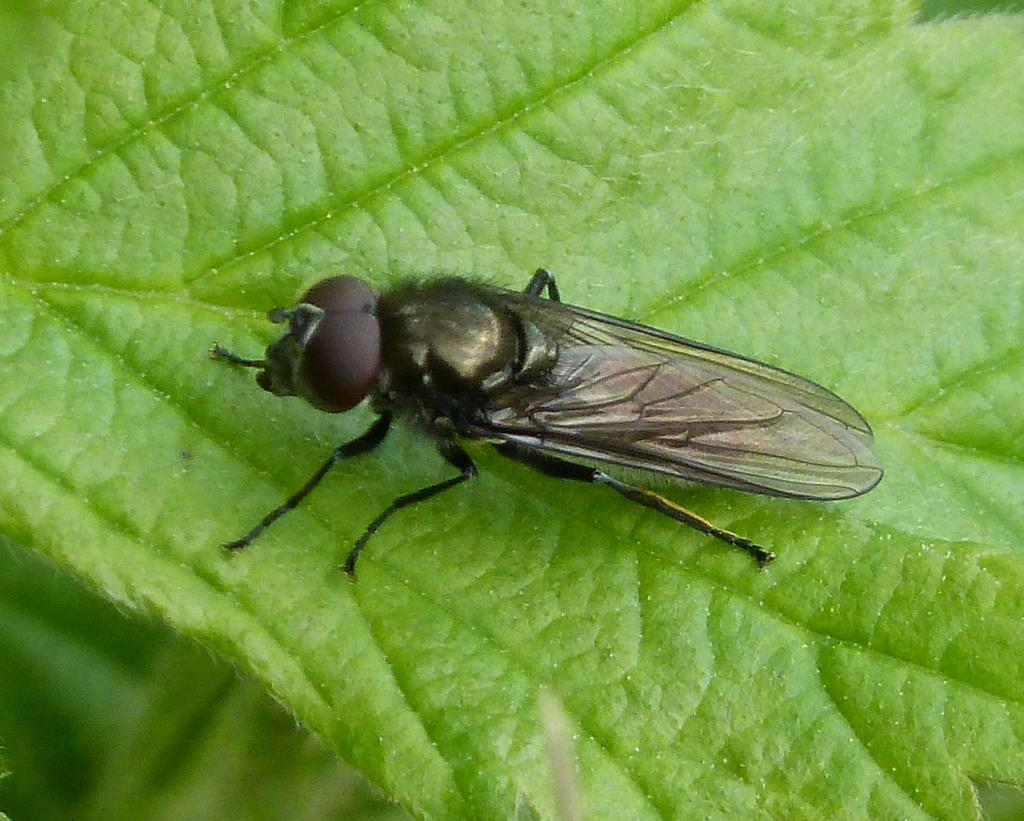What is the main subject in the middle of the image? There is a fly in the middle of the image. What can be seen at the bottom of the image? There is a leaf at the bottom of the image. What type of juice is being served in the image? There is no juice present in the image; it only features a fly and a leaf. How many ladybugs can be seen in the image? There are no ladybugs present in the image. 